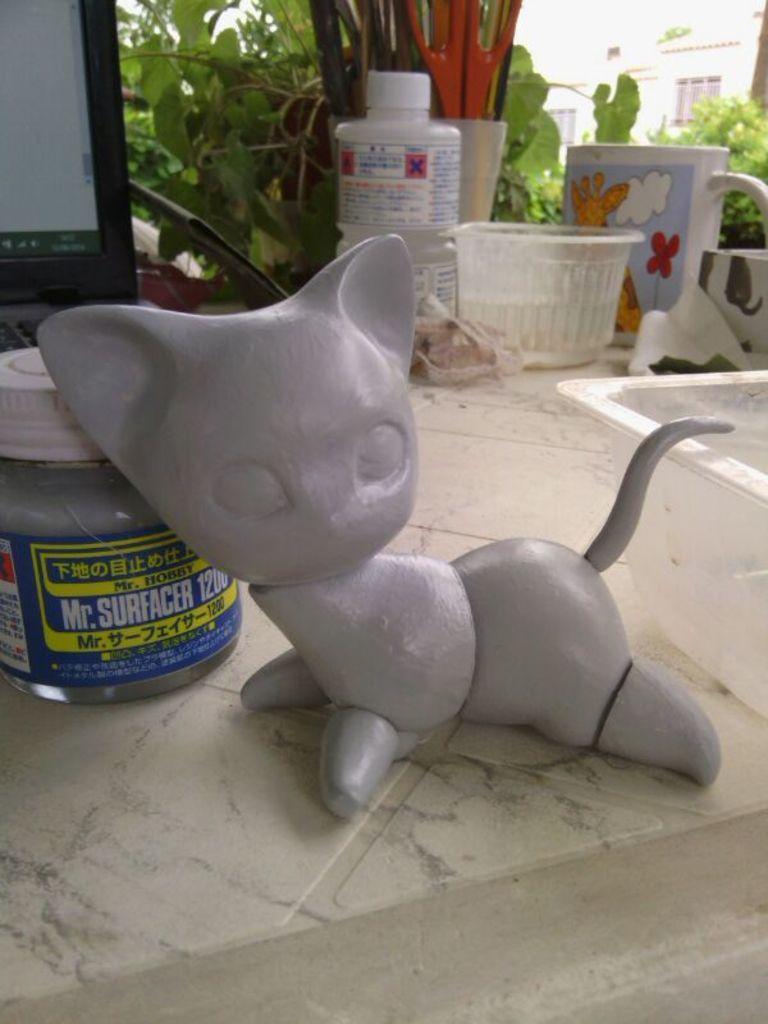In one or two sentences, can you explain what this image depicts? In this image we can see a cat toy, a jar on which we can see a label, laptop, a few more jars, container, cup, scissors and the glass window through which we can see buildings in the background. 